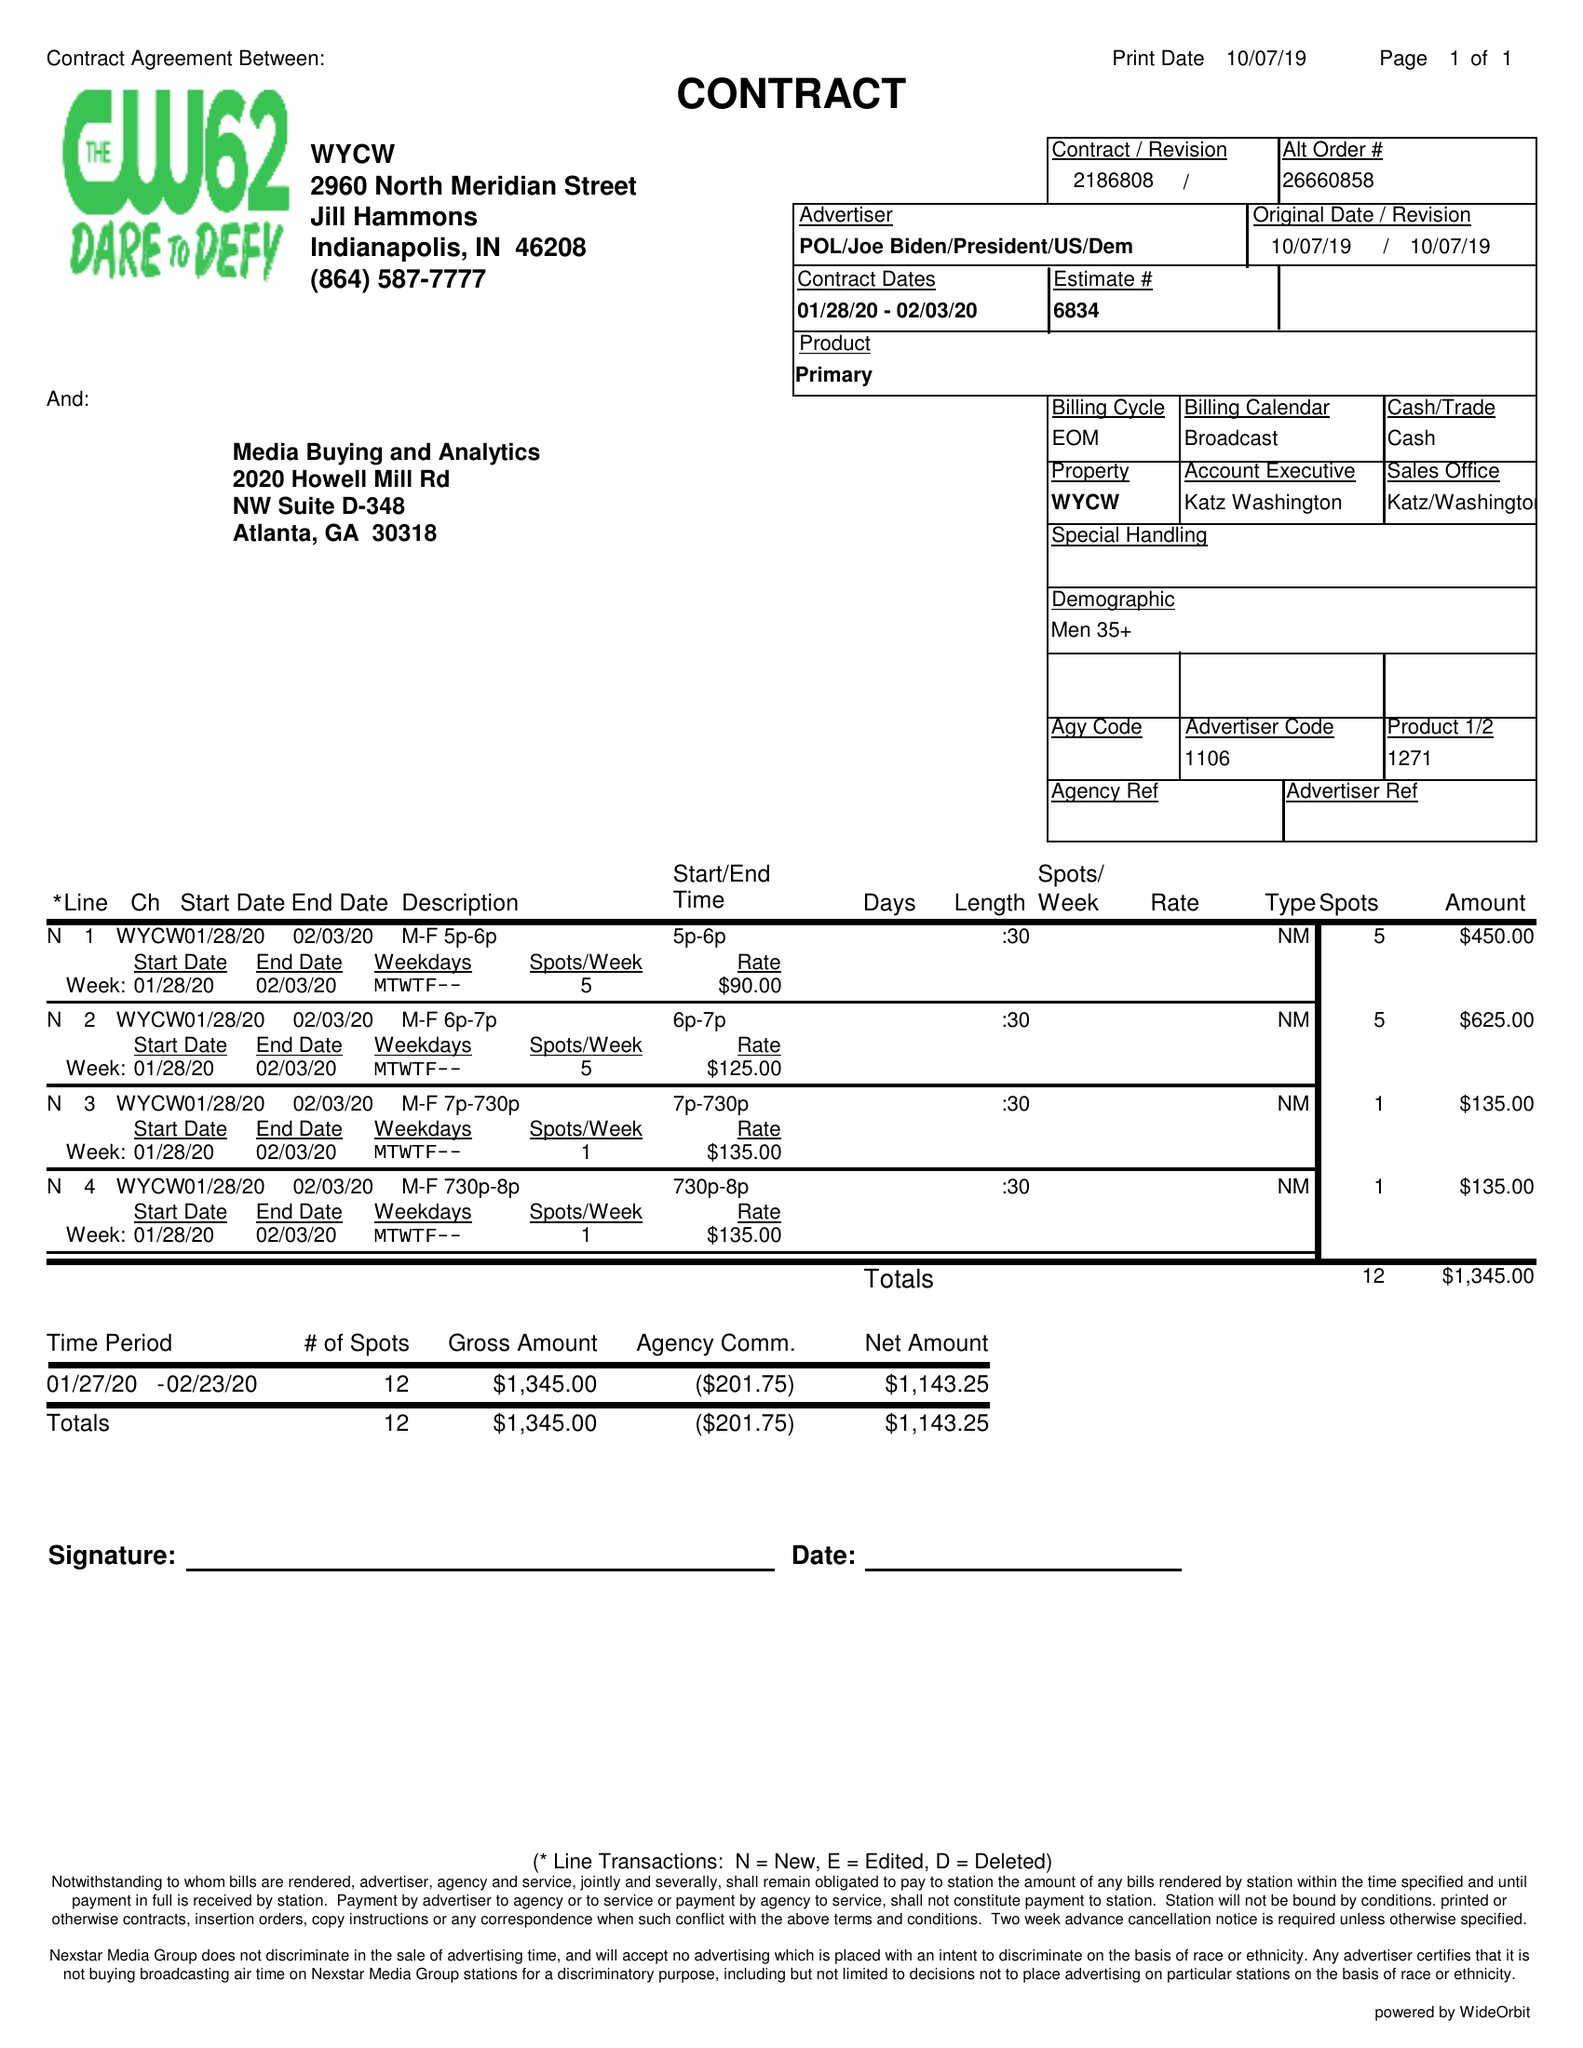What is the value for the flight_to?
Answer the question using a single word or phrase. 02/03/20 